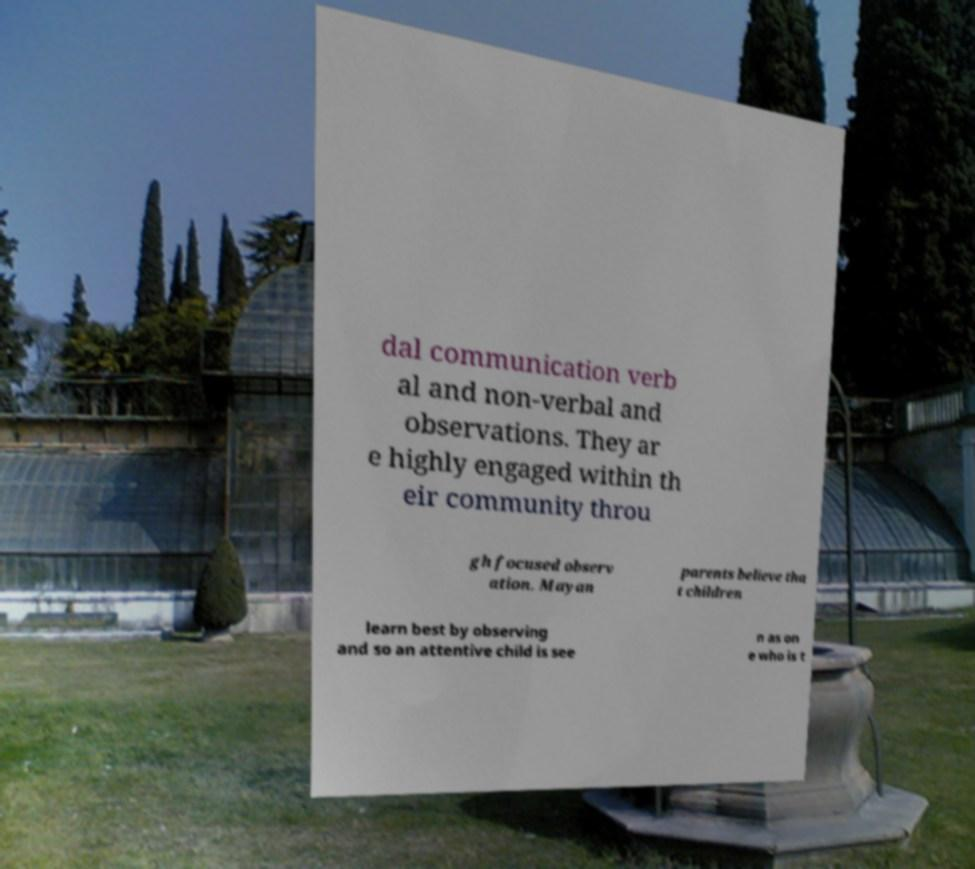Could you extract and type out the text from this image? dal communication verb al and non-verbal and observations. They ar e highly engaged within th eir community throu gh focused observ ation. Mayan parents believe tha t children learn best by observing and so an attentive child is see n as on e who is t 